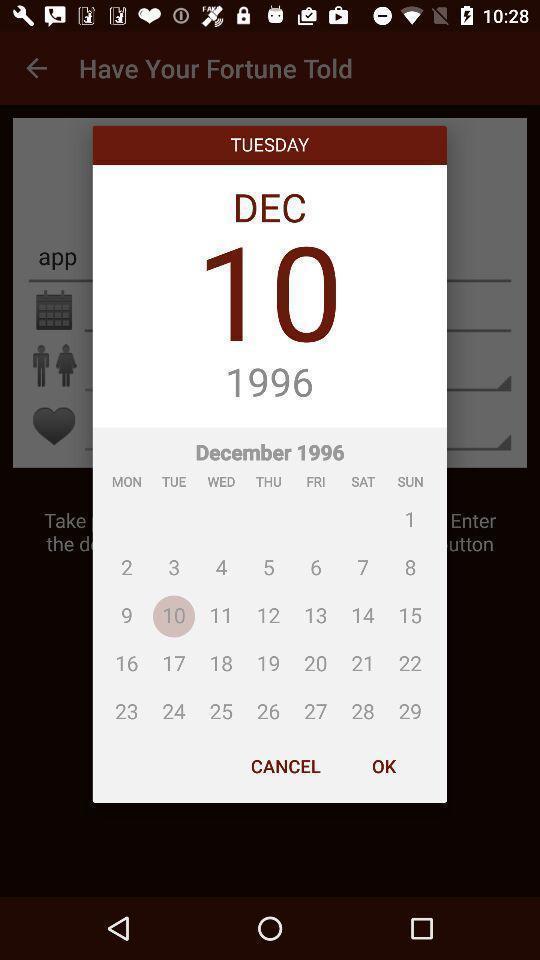Please provide a description for this image. Popup showing about different dates in calendar. 